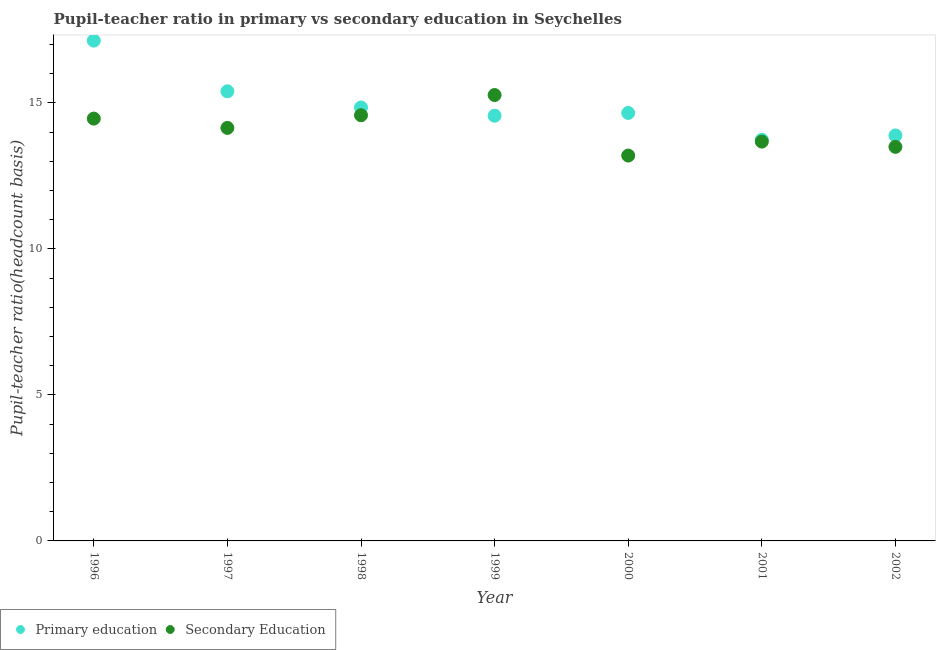What is the pupil-teacher ratio in primary education in 2002?
Offer a terse response. 13.89. Across all years, what is the maximum pupil-teacher ratio in primary education?
Provide a short and direct response. 17.13. Across all years, what is the minimum pupil teacher ratio on secondary education?
Your answer should be compact. 13.2. What is the total pupil teacher ratio on secondary education in the graph?
Provide a short and direct response. 98.82. What is the difference between the pupil-teacher ratio in primary education in 1996 and that in 1997?
Give a very brief answer. 1.74. What is the difference between the pupil-teacher ratio in primary education in 2001 and the pupil teacher ratio on secondary education in 1999?
Your answer should be very brief. -1.53. What is the average pupil-teacher ratio in primary education per year?
Your answer should be compact. 14.89. In the year 2000, what is the difference between the pupil teacher ratio on secondary education and pupil-teacher ratio in primary education?
Keep it short and to the point. -1.46. What is the ratio of the pupil-teacher ratio in primary education in 1997 to that in 1998?
Provide a short and direct response. 1.04. Is the pupil teacher ratio on secondary education in 1998 less than that in 1999?
Provide a short and direct response. Yes. What is the difference between the highest and the second highest pupil-teacher ratio in primary education?
Ensure brevity in your answer.  1.74. What is the difference between the highest and the lowest pupil-teacher ratio in primary education?
Provide a succinct answer. 3.39. In how many years, is the pupil-teacher ratio in primary education greater than the average pupil-teacher ratio in primary education taken over all years?
Provide a succinct answer. 2. Is the pupil-teacher ratio in primary education strictly less than the pupil teacher ratio on secondary education over the years?
Provide a short and direct response. No. What is the difference between two consecutive major ticks on the Y-axis?
Your answer should be compact. 5. Does the graph contain any zero values?
Provide a short and direct response. No. Does the graph contain grids?
Your answer should be compact. No. Where does the legend appear in the graph?
Keep it short and to the point. Bottom left. How many legend labels are there?
Offer a very short reply. 2. How are the legend labels stacked?
Keep it short and to the point. Horizontal. What is the title of the graph?
Ensure brevity in your answer.  Pupil-teacher ratio in primary vs secondary education in Seychelles. What is the label or title of the Y-axis?
Your answer should be compact. Pupil-teacher ratio(headcount basis). What is the Pupil-teacher ratio(headcount basis) of Primary education in 1996?
Your answer should be compact. 17.13. What is the Pupil-teacher ratio(headcount basis) of Secondary Education in 1996?
Provide a succinct answer. 14.46. What is the Pupil-teacher ratio(headcount basis) of Primary education in 1997?
Offer a terse response. 15.4. What is the Pupil-teacher ratio(headcount basis) of Secondary Education in 1997?
Keep it short and to the point. 14.14. What is the Pupil-teacher ratio(headcount basis) in Primary education in 1998?
Give a very brief answer. 14.84. What is the Pupil-teacher ratio(headcount basis) in Secondary Education in 1998?
Make the answer very short. 14.58. What is the Pupil-teacher ratio(headcount basis) of Primary education in 1999?
Your answer should be very brief. 14.56. What is the Pupil-teacher ratio(headcount basis) of Secondary Education in 1999?
Your answer should be compact. 15.27. What is the Pupil-teacher ratio(headcount basis) of Primary education in 2000?
Offer a very short reply. 14.66. What is the Pupil-teacher ratio(headcount basis) of Secondary Education in 2000?
Make the answer very short. 13.2. What is the Pupil-teacher ratio(headcount basis) in Primary education in 2001?
Provide a short and direct response. 13.74. What is the Pupil-teacher ratio(headcount basis) in Secondary Education in 2001?
Your answer should be compact. 13.68. What is the Pupil-teacher ratio(headcount basis) of Primary education in 2002?
Your answer should be very brief. 13.89. What is the Pupil-teacher ratio(headcount basis) in Secondary Education in 2002?
Make the answer very short. 13.49. Across all years, what is the maximum Pupil-teacher ratio(headcount basis) of Primary education?
Provide a short and direct response. 17.13. Across all years, what is the maximum Pupil-teacher ratio(headcount basis) in Secondary Education?
Offer a very short reply. 15.27. Across all years, what is the minimum Pupil-teacher ratio(headcount basis) of Primary education?
Your answer should be very brief. 13.74. Across all years, what is the minimum Pupil-teacher ratio(headcount basis) in Secondary Education?
Your response must be concise. 13.2. What is the total Pupil-teacher ratio(headcount basis) in Primary education in the graph?
Ensure brevity in your answer.  104.22. What is the total Pupil-teacher ratio(headcount basis) of Secondary Education in the graph?
Make the answer very short. 98.82. What is the difference between the Pupil-teacher ratio(headcount basis) in Primary education in 1996 and that in 1997?
Provide a succinct answer. 1.74. What is the difference between the Pupil-teacher ratio(headcount basis) in Secondary Education in 1996 and that in 1997?
Offer a terse response. 0.32. What is the difference between the Pupil-teacher ratio(headcount basis) in Primary education in 1996 and that in 1998?
Make the answer very short. 2.29. What is the difference between the Pupil-teacher ratio(headcount basis) of Secondary Education in 1996 and that in 1998?
Make the answer very short. -0.11. What is the difference between the Pupil-teacher ratio(headcount basis) of Primary education in 1996 and that in 1999?
Keep it short and to the point. 2.57. What is the difference between the Pupil-teacher ratio(headcount basis) of Secondary Education in 1996 and that in 1999?
Provide a short and direct response. -0.81. What is the difference between the Pupil-teacher ratio(headcount basis) in Primary education in 1996 and that in 2000?
Ensure brevity in your answer.  2.48. What is the difference between the Pupil-teacher ratio(headcount basis) in Secondary Education in 1996 and that in 2000?
Your response must be concise. 1.27. What is the difference between the Pupil-teacher ratio(headcount basis) of Primary education in 1996 and that in 2001?
Your answer should be very brief. 3.39. What is the difference between the Pupil-teacher ratio(headcount basis) in Secondary Education in 1996 and that in 2001?
Make the answer very short. 0.79. What is the difference between the Pupil-teacher ratio(headcount basis) of Primary education in 1996 and that in 2002?
Provide a short and direct response. 3.25. What is the difference between the Pupil-teacher ratio(headcount basis) of Secondary Education in 1996 and that in 2002?
Provide a succinct answer. 0.97. What is the difference between the Pupil-teacher ratio(headcount basis) of Primary education in 1997 and that in 1998?
Offer a very short reply. 0.55. What is the difference between the Pupil-teacher ratio(headcount basis) in Secondary Education in 1997 and that in 1998?
Your response must be concise. -0.43. What is the difference between the Pupil-teacher ratio(headcount basis) in Primary education in 1997 and that in 1999?
Provide a short and direct response. 0.84. What is the difference between the Pupil-teacher ratio(headcount basis) of Secondary Education in 1997 and that in 1999?
Give a very brief answer. -1.13. What is the difference between the Pupil-teacher ratio(headcount basis) of Primary education in 1997 and that in 2000?
Your answer should be compact. 0.74. What is the difference between the Pupil-teacher ratio(headcount basis) of Secondary Education in 1997 and that in 2000?
Your answer should be compact. 0.95. What is the difference between the Pupil-teacher ratio(headcount basis) in Primary education in 1997 and that in 2001?
Give a very brief answer. 1.66. What is the difference between the Pupil-teacher ratio(headcount basis) of Secondary Education in 1997 and that in 2001?
Offer a very short reply. 0.47. What is the difference between the Pupil-teacher ratio(headcount basis) of Primary education in 1997 and that in 2002?
Give a very brief answer. 1.51. What is the difference between the Pupil-teacher ratio(headcount basis) in Secondary Education in 1997 and that in 2002?
Give a very brief answer. 0.65. What is the difference between the Pupil-teacher ratio(headcount basis) in Primary education in 1998 and that in 1999?
Ensure brevity in your answer.  0.28. What is the difference between the Pupil-teacher ratio(headcount basis) in Secondary Education in 1998 and that in 1999?
Make the answer very short. -0.69. What is the difference between the Pupil-teacher ratio(headcount basis) in Primary education in 1998 and that in 2000?
Make the answer very short. 0.19. What is the difference between the Pupil-teacher ratio(headcount basis) of Secondary Education in 1998 and that in 2000?
Ensure brevity in your answer.  1.38. What is the difference between the Pupil-teacher ratio(headcount basis) of Primary education in 1998 and that in 2001?
Your answer should be very brief. 1.11. What is the difference between the Pupil-teacher ratio(headcount basis) in Secondary Education in 1998 and that in 2001?
Provide a short and direct response. 0.9. What is the difference between the Pupil-teacher ratio(headcount basis) in Primary education in 1998 and that in 2002?
Keep it short and to the point. 0.96. What is the difference between the Pupil-teacher ratio(headcount basis) of Secondary Education in 1998 and that in 2002?
Offer a very short reply. 1.08. What is the difference between the Pupil-teacher ratio(headcount basis) of Primary education in 1999 and that in 2000?
Offer a terse response. -0.09. What is the difference between the Pupil-teacher ratio(headcount basis) of Secondary Education in 1999 and that in 2000?
Provide a succinct answer. 2.07. What is the difference between the Pupil-teacher ratio(headcount basis) of Primary education in 1999 and that in 2001?
Provide a short and direct response. 0.82. What is the difference between the Pupil-teacher ratio(headcount basis) in Secondary Education in 1999 and that in 2001?
Your response must be concise. 1.59. What is the difference between the Pupil-teacher ratio(headcount basis) in Primary education in 1999 and that in 2002?
Your answer should be very brief. 0.68. What is the difference between the Pupil-teacher ratio(headcount basis) of Secondary Education in 1999 and that in 2002?
Give a very brief answer. 1.78. What is the difference between the Pupil-teacher ratio(headcount basis) of Primary education in 2000 and that in 2001?
Provide a short and direct response. 0.92. What is the difference between the Pupil-teacher ratio(headcount basis) in Secondary Education in 2000 and that in 2001?
Your response must be concise. -0.48. What is the difference between the Pupil-teacher ratio(headcount basis) of Primary education in 2000 and that in 2002?
Provide a short and direct response. 0.77. What is the difference between the Pupil-teacher ratio(headcount basis) of Secondary Education in 2000 and that in 2002?
Provide a short and direct response. -0.3. What is the difference between the Pupil-teacher ratio(headcount basis) in Primary education in 2001 and that in 2002?
Your answer should be very brief. -0.15. What is the difference between the Pupil-teacher ratio(headcount basis) of Secondary Education in 2001 and that in 2002?
Your answer should be very brief. 0.18. What is the difference between the Pupil-teacher ratio(headcount basis) of Primary education in 1996 and the Pupil-teacher ratio(headcount basis) of Secondary Education in 1997?
Your response must be concise. 2.99. What is the difference between the Pupil-teacher ratio(headcount basis) in Primary education in 1996 and the Pupil-teacher ratio(headcount basis) in Secondary Education in 1998?
Your response must be concise. 2.56. What is the difference between the Pupil-teacher ratio(headcount basis) of Primary education in 1996 and the Pupil-teacher ratio(headcount basis) of Secondary Education in 1999?
Your response must be concise. 1.86. What is the difference between the Pupil-teacher ratio(headcount basis) in Primary education in 1996 and the Pupil-teacher ratio(headcount basis) in Secondary Education in 2000?
Give a very brief answer. 3.94. What is the difference between the Pupil-teacher ratio(headcount basis) of Primary education in 1996 and the Pupil-teacher ratio(headcount basis) of Secondary Education in 2001?
Ensure brevity in your answer.  3.46. What is the difference between the Pupil-teacher ratio(headcount basis) in Primary education in 1996 and the Pupil-teacher ratio(headcount basis) in Secondary Education in 2002?
Give a very brief answer. 3.64. What is the difference between the Pupil-teacher ratio(headcount basis) in Primary education in 1997 and the Pupil-teacher ratio(headcount basis) in Secondary Education in 1998?
Offer a very short reply. 0.82. What is the difference between the Pupil-teacher ratio(headcount basis) of Primary education in 1997 and the Pupil-teacher ratio(headcount basis) of Secondary Education in 1999?
Make the answer very short. 0.13. What is the difference between the Pupil-teacher ratio(headcount basis) of Primary education in 1997 and the Pupil-teacher ratio(headcount basis) of Secondary Education in 2000?
Your answer should be compact. 2.2. What is the difference between the Pupil-teacher ratio(headcount basis) in Primary education in 1997 and the Pupil-teacher ratio(headcount basis) in Secondary Education in 2001?
Keep it short and to the point. 1.72. What is the difference between the Pupil-teacher ratio(headcount basis) in Primary education in 1997 and the Pupil-teacher ratio(headcount basis) in Secondary Education in 2002?
Ensure brevity in your answer.  1.9. What is the difference between the Pupil-teacher ratio(headcount basis) of Primary education in 1998 and the Pupil-teacher ratio(headcount basis) of Secondary Education in 1999?
Provide a succinct answer. -0.43. What is the difference between the Pupil-teacher ratio(headcount basis) of Primary education in 1998 and the Pupil-teacher ratio(headcount basis) of Secondary Education in 2000?
Offer a terse response. 1.65. What is the difference between the Pupil-teacher ratio(headcount basis) in Primary education in 1998 and the Pupil-teacher ratio(headcount basis) in Secondary Education in 2001?
Make the answer very short. 1.17. What is the difference between the Pupil-teacher ratio(headcount basis) of Primary education in 1998 and the Pupil-teacher ratio(headcount basis) of Secondary Education in 2002?
Provide a succinct answer. 1.35. What is the difference between the Pupil-teacher ratio(headcount basis) in Primary education in 1999 and the Pupil-teacher ratio(headcount basis) in Secondary Education in 2000?
Your answer should be compact. 1.36. What is the difference between the Pupil-teacher ratio(headcount basis) of Primary education in 1999 and the Pupil-teacher ratio(headcount basis) of Secondary Education in 2001?
Provide a short and direct response. 0.89. What is the difference between the Pupil-teacher ratio(headcount basis) of Primary education in 1999 and the Pupil-teacher ratio(headcount basis) of Secondary Education in 2002?
Provide a short and direct response. 1.07. What is the difference between the Pupil-teacher ratio(headcount basis) in Primary education in 2000 and the Pupil-teacher ratio(headcount basis) in Secondary Education in 2001?
Your answer should be compact. 0.98. What is the difference between the Pupil-teacher ratio(headcount basis) of Primary education in 2000 and the Pupil-teacher ratio(headcount basis) of Secondary Education in 2002?
Your response must be concise. 1.16. What is the difference between the Pupil-teacher ratio(headcount basis) of Primary education in 2001 and the Pupil-teacher ratio(headcount basis) of Secondary Education in 2002?
Provide a succinct answer. 0.24. What is the average Pupil-teacher ratio(headcount basis) in Primary education per year?
Offer a terse response. 14.89. What is the average Pupil-teacher ratio(headcount basis) of Secondary Education per year?
Your answer should be compact. 14.12. In the year 1996, what is the difference between the Pupil-teacher ratio(headcount basis) of Primary education and Pupil-teacher ratio(headcount basis) of Secondary Education?
Your response must be concise. 2.67. In the year 1997, what is the difference between the Pupil-teacher ratio(headcount basis) of Primary education and Pupil-teacher ratio(headcount basis) of Secondary Education?
Offer a terse response. 1.25. In the year 1998, what is the difference between the Pupil-teacher ratio(headcount basis) of Primary education and Pupil-teacher ratio(headcount basis) of Secondary Education?
Make the answer very short. 0.27. In the year 1999, what is the difference between the Pupil-teacher ratio(headcount basis) of Primary education and Pupil-teacher ratio(headcount basis) of Secondary Education?
Offer a terse response. -0.71. In the year 2000, what is the difference between the Pupil-teacher ratio(headcount basis) in Primary education and Pupil-teacher ratio(headcount basis) in Secondary Education?
Offer a very short reply. 1.46. In the year 2001, what is the difference between the Pupil-teacher ratio(headcount basis) in Primary education and Pupil-teacher ratio(headcount basis) in Secondary Education?
Make the answer very short. 0.06. In the year 2002, what is the difference between the Pupil-teacher ratio(headcount basis) of Primary education and Pupil-teacher ratio(headcount basis) of Secondary Education?
Your answer should be compact. 0.39. What is the ratio of the Pupil-teacher ratio(headcount basis) of Primary education in 1996 to that in 1997?
Provide a succinct answer. 1.11. What is the ratio of the Pupil-teacher ratio(headcount basis) of Secondary Education in 1996 to that in 1997?
Provide a succinct answer. 1.02. What is the ratio of the Pupil-teacher ratio(headcount basis) of Primary education in 1996 to that in 1998?
Offer a terse response. 1.15. What is the ratio of the Pupil-teacher ratio(headcount basis) in Secondary Education in 1996 to that in 1998?
Offer a terse response. 0.99. What is the ratio of the Pupil-teacher ratio(headcount basis) in Primary education in 1996 to that in 1999?
Your answer should be very brief. 1.18. What is the ratio of the Pupil-teacher ratio(headcount basis) of Secondary Education in 1996 to that in 1999?
Make the answer very short. 0.95. What is the ratio of the Pupil-teacher ratio(headcount basis) in Primary education in 1996 to that in 2000?
Your response must be concise. 1.17. What is the ratio of the Pupil-teacher ratio(headcount basis) of Secondary Education in 1996 to that in 2000?
Your response must be concise. 1.1. What is the ratio of the Pupil-teacher ratio(headcount basis) of Primary education in 1996 to that in 2001?
Provide a short and direct response. 1.25. What is the ratio of the Pupil-teacher ratio(headcount basis) of Secondary Education in 1996 to that in 2001?
Provide a short and direct response. 1.06. What is the ratio of the Pupil-teacher ratio(headcount basis) in Primary education in 1996 to that in 2002?
Offer a very short reply. 1.23. What is the ratio of the Pupil-teacher ratio(headcount basis) in Secondary Education in 1996 to that in 2002?
Your answer should be very brief. 1.07. What is the ratio of the Pupil-teacher ratio(headcount basis) in Primary education in 1997 to that in 1998?
Your answer should be very brief. 1.04. What is the ratio of the Pupil-teacher ratio(headcount basis) of Secondary Education in 1997 to that in 1998?
Provide a succinct answer. 0.97. What is the ratio of the Pupil-teacher ratio(headcount basis) in Primary education in 1997 to that in 1999?
Offer a terse response. 1.06. What is the ratio of the Pupil-teacher ratio(headcount basis) in Secondary Education in 1997 to that in 1999?
Keep it short and to the point. 0.93. What is the ratio of the Pupil-teacher ratio(headcount basis) in Primary education in 1997 to that in 2000?
Keep it short and to the point. 1.05. What is the ratio of the Pupil-teacher ratio(headcount basis) of Secondary Education in 1997 to that in 2000?
Make the answer very short. 1.07. What is the ratio of the Pupil-teacher ratio(headcount basis) in Primary education in 1997 to that in 2001?
Your answer should be very brief. 1.12. What is the ratio of the Pupil-teacher ratio(headcount basis) of Secondary Education in 1997 to that in 2001?
Your response must be concise. 1.03. What is the ratio of the Pupil-teacher ratio(headcount basis) in Primary education in 1997 to that in 2002?
Offer a terse response. 1.11. What is the ratio of the Pupil-teacher ratio(headcount basis) of Secondary Education in 1997 to that in 2002?
Ensure brevity in your answer.  1.05. What is the ratio of the Pupil-teacher ratio(headcount basis) of Primary education in 1998 to that in 1999?
Ensure brevity in your answer.  1.02. What is the ratio of the Pupil-teacher ratio(headcount basis) in Secondary Education in 1998 to that in 1999?
Provide a succinct answer. 0.95. What is the ratio of the Pupil-teacher ratio(headcount basis) in Primary education in 1998 to that in 2000?
Provide a short and direct response. 1.01. What is the ratio of the Pupil-teacher ratio(headcount basis) in Secondary Education in 1998 to that in 2000?
Offer a terse response. 1.1. What is the ratio of the Pupil-teacher ratio(headcount basis) of Primary education in 1998 to that in 2001?
Provide a short and direct response. 1.08. What is the ratio of the Pupil-teacher ratio(headcount basis) in Secondary Education in 1998 to that in 2001?
Offer a terse response. 1.07. What is the ratio of the Pupil-teacher ratio(headcount basis) in Primary education in 1998 to that in 2002?
Provide a short and direct response. 1.07. What is the ratio of the Pupil-teacher ratio(headcount basis) of Secondary Education in 1998 to that in 2002?
Make the answer very short. 1.08. What is the ratio of the Pupil-teacher ratio(headcount basis) of Primary education in 1999 to that in 2000?
Offer a terse response. 0.99. What is the ratio of the Pupil-teacher ratio(headcount basis) of Secondary Education in 1999 to that in 2000?
Keep it short and to the point. 1.16. What is the ratio of the Pupil-teacher ratio(headcount basis) of Primary education in 1999 to that in 2001?
Offer a very short reply. 1.06. What is the ratio of the Pupil-teacher ratio(headcount basis) in Secondary Education in 1999 to that in 2001?
Keep it short and to the point. 1.12. What is the ratio of the Pupil-teacher ratio(headcount basis) of Primary education in 1999 to that in 2002?
Your response must be concise. 1.05. What is the ratio of the Pupil-teacher ratio(headcount basis) of Secondary Education in 1999 to that in 2002?
Make the answer very short. 1.13. What is the ratio of the Pupil-teacher ratio(headcount basis) of Primary education in 2000 to that in 2001?
Keep it short and to the point. 1.07. What is the ratio of the Pupil-teacher ratio(headcount basis) of Secondary Education in 2000 to that in 2001?
Your answer should be compact. 0.96. What is the ratio of the Pupil-teacher ratio(headcount basis) in Primary education in 2000 to that in 2002?
Provide a succinct answer. 1.06. What is the ratio of the Pupil-teacher ratio(headcount basis) in Secondary Education in 2000 to that in 2002?
Your answer should be very brief. 0.98. What is the ratio of the Pupil-teacher ratio(headcount basis) in Secondary Education in 2001 to that in 2002?
Your answer should be compact. 1.01. What is the difference between the highest and the second highest Pupil-teacher ratio(headcount basis) in Primary education?
Offer a very short reply. 1.74. What is the difference between the highest and the second highest Pupil-teacher ratio(headcount basis) of Secondary Education?
Your response must be concise. 0.69. What is the difference between the highest and the lowest Pupil-teacher ratio(headcount basis) of Primary education?
Give a very brief answer. 3.39. What is the difference between the highest and the lowest Pupil-teacher ratio(headcount basis) of Secondary Education?
Ensure brevity in your answer.  2.07. 